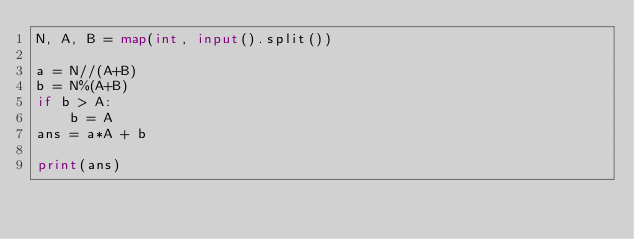Convert code to text. <code><loc_0><loc_0><loc_500><loc_500><_Python_>N, A, B = map(int, input().split())

a = N//(A+B)
b = N%(A+B)
if b > A:
    b = A
ans = a*A + b

print(ans)</code> 